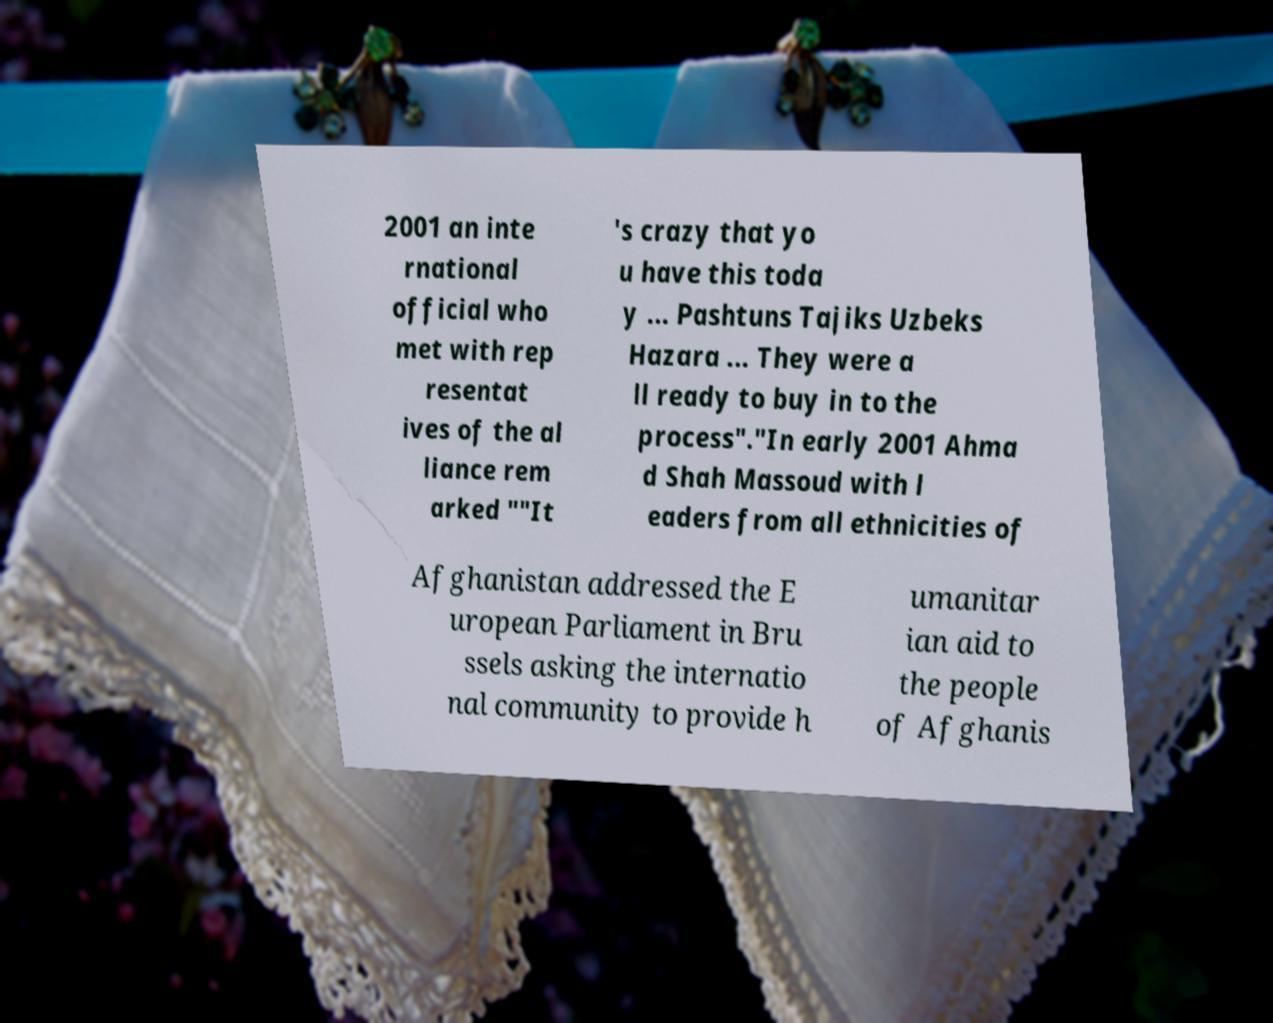Could you assist in decoding the text presented in this image and type it out clearly? 2001 an inte rnational official who met with rep resentat ives of the al liance rem arked ""It 's crazy that yo u have this toda y ... Pashtuns Tajiks Uzbeks Hazara ... They were a ll ready to buy in to the process"."In early 2001 Ahma d Shah Massoud with l eaders from all ethnicities of Afghanistan addressed the E uropean Parliament in Bru ssels asking the internatio nal community to provide h umanitar ian aid to the people of Afghanis 